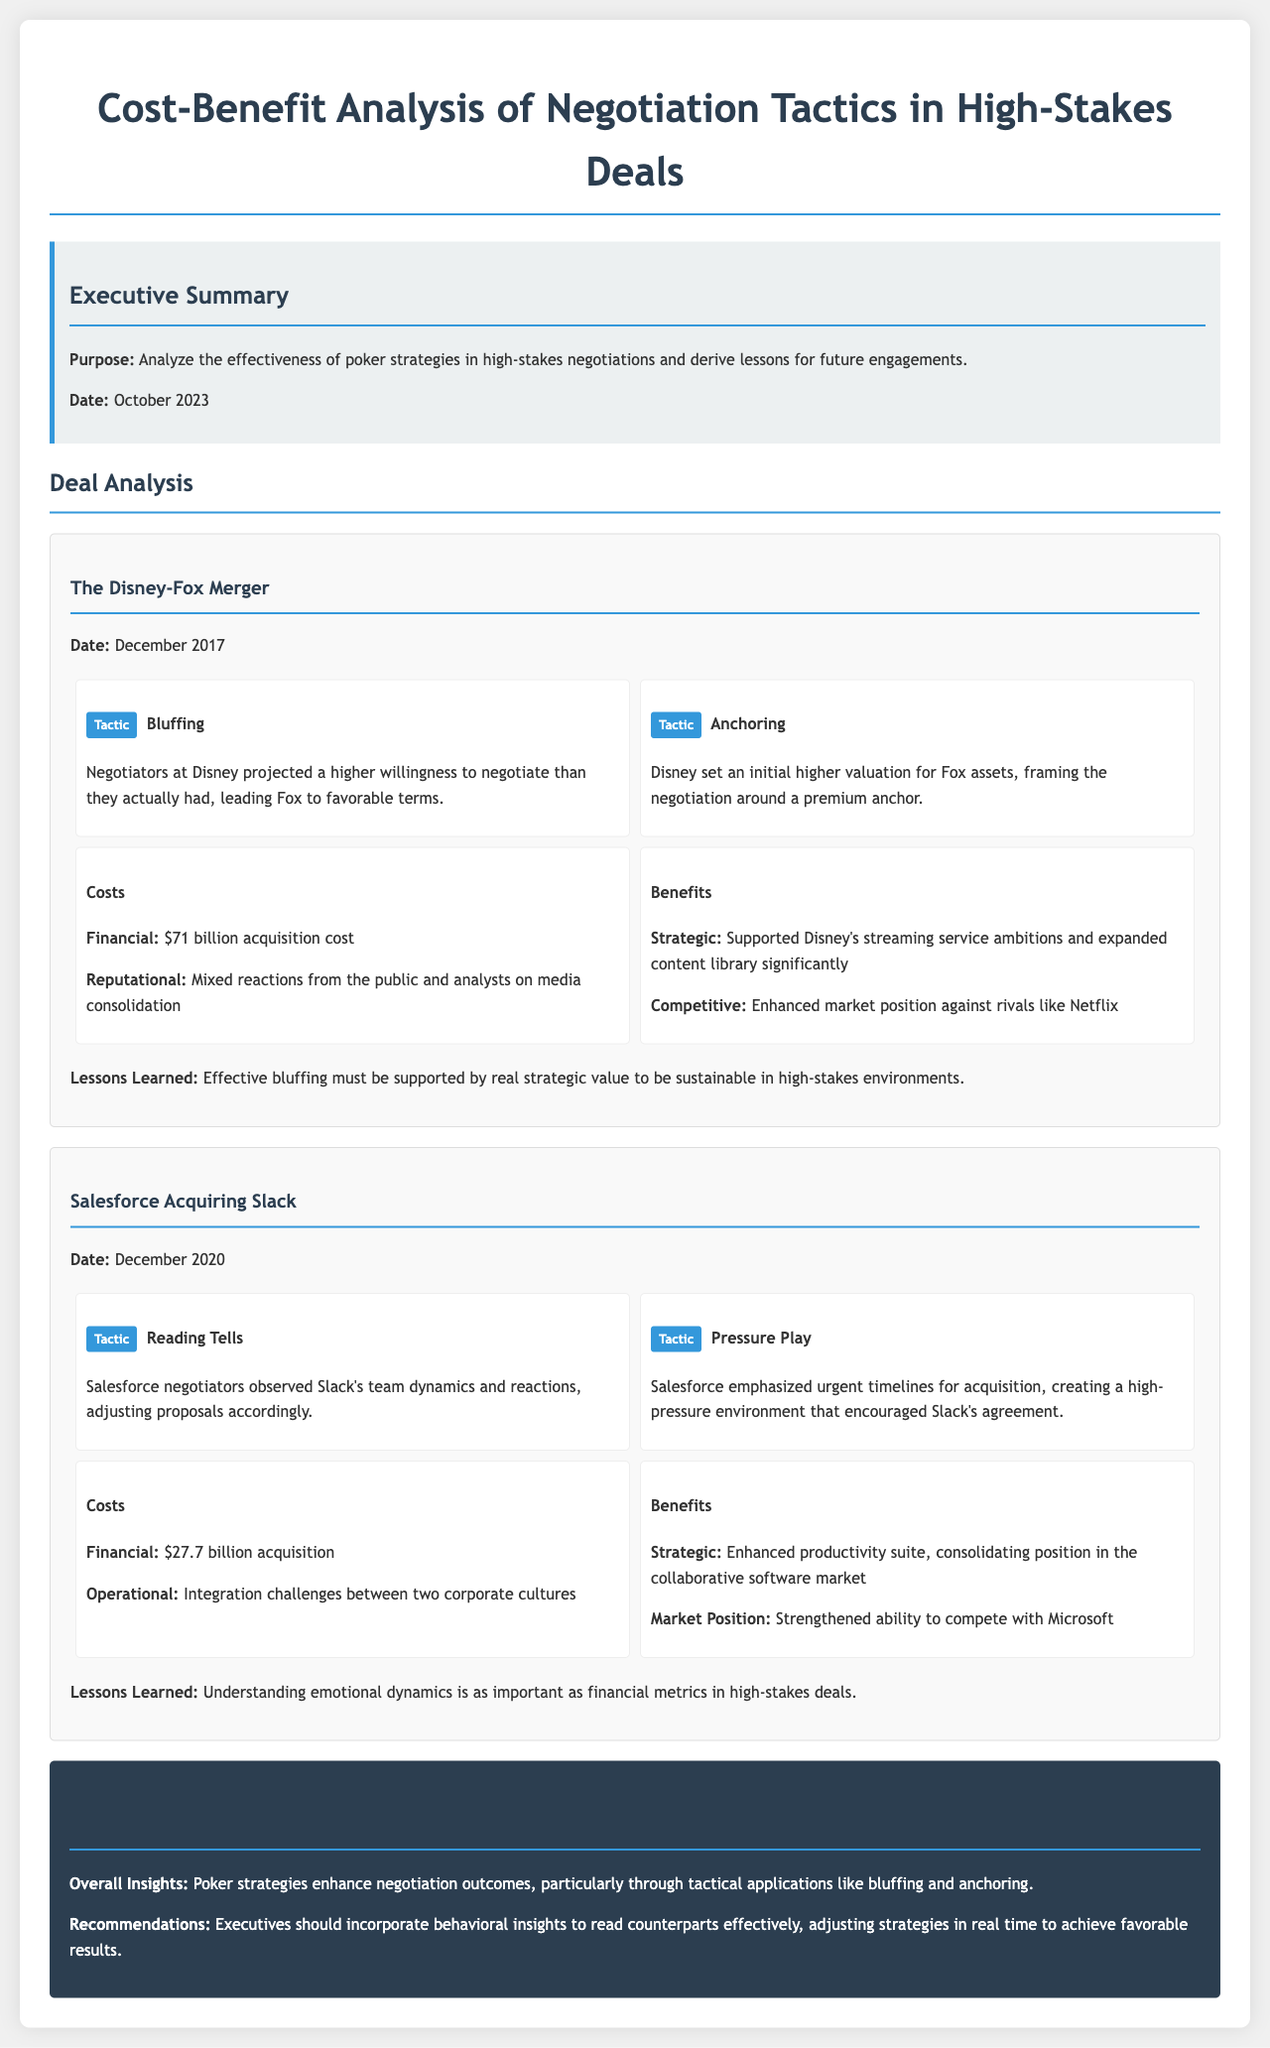what is the purpose of the document? The document aims to analyze the effectiveness of poker strategies in high-stakes negotiations and derive lessons for future engagements.
Answer: Analyze the effectiveness of poker strategies what was the acquisition cost of Disney-Fox merger? The financial cost listed for the Disney-Fox merger is $71 billion.
Answer: $71 billion which tactic involved setting an initial higher valuation? The tactic that involved setting an initial higher valuation is Anchoring.
Answer: Anchoring what were the benefits of the Salesforce acquisition of Slack? The benefits included an enhanced productivity suite and strengthened ability to compete with Microsoft.
Answer: Enhanced productivity suite what does the document suggest is as important as financial metrics? The document suggests that understanding emotional dynamics is as important as financial metrics.
Answer: Understanding emotional dynamics when did the Disney-Fox merger take place? The Disney-Fox merger took place in December 2017.
Answer: December 2017 what lesson was learned from the Disney-Fox merger regarding bluffing? The lesson learned was that effective bluffing must be supported by real strategic value to be sustainable.
Answer: Effective bluffing must be supported by real strategic value what was a major cost of the Salesforce acquisition? A major cost of the Salesforce acquisition was operational integration challenges between the two corporate cultures.
Answer: Integration challenges what is a key recommendation for executives based on the document's insights? A key recommendation for executives is to incorporate behavioral insights to read counterparts effectively.
Answer: Incorporate behavioral insights 